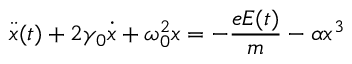Convert formula to latex. <formula><loc_0><loc_0><loc_500><loc_500>\ D d o t { x } ( t ) + 2 \gamma _ { 0 } \ D o t { x } + \omega _ { 0 } ^ { 2 } x = - \frac { e E ( t ) } { m } - \alpha x ^ { 3 }</formula> 